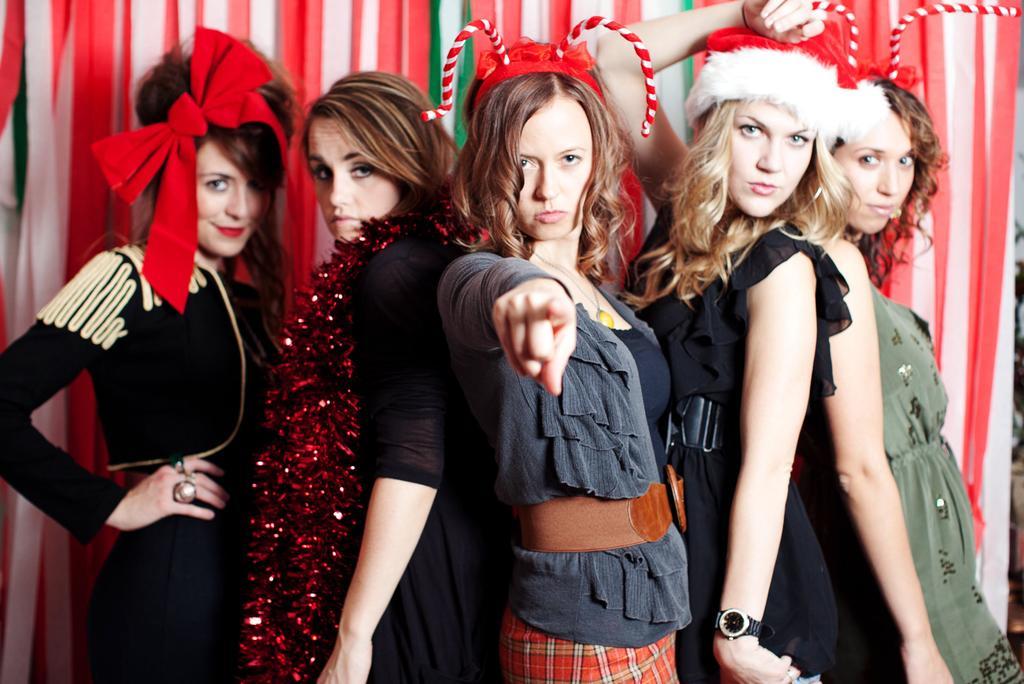Please provide a concise description of this image. As we can see in the image in the front there are group of people standing. Behind them there is a curtain and a wall. 